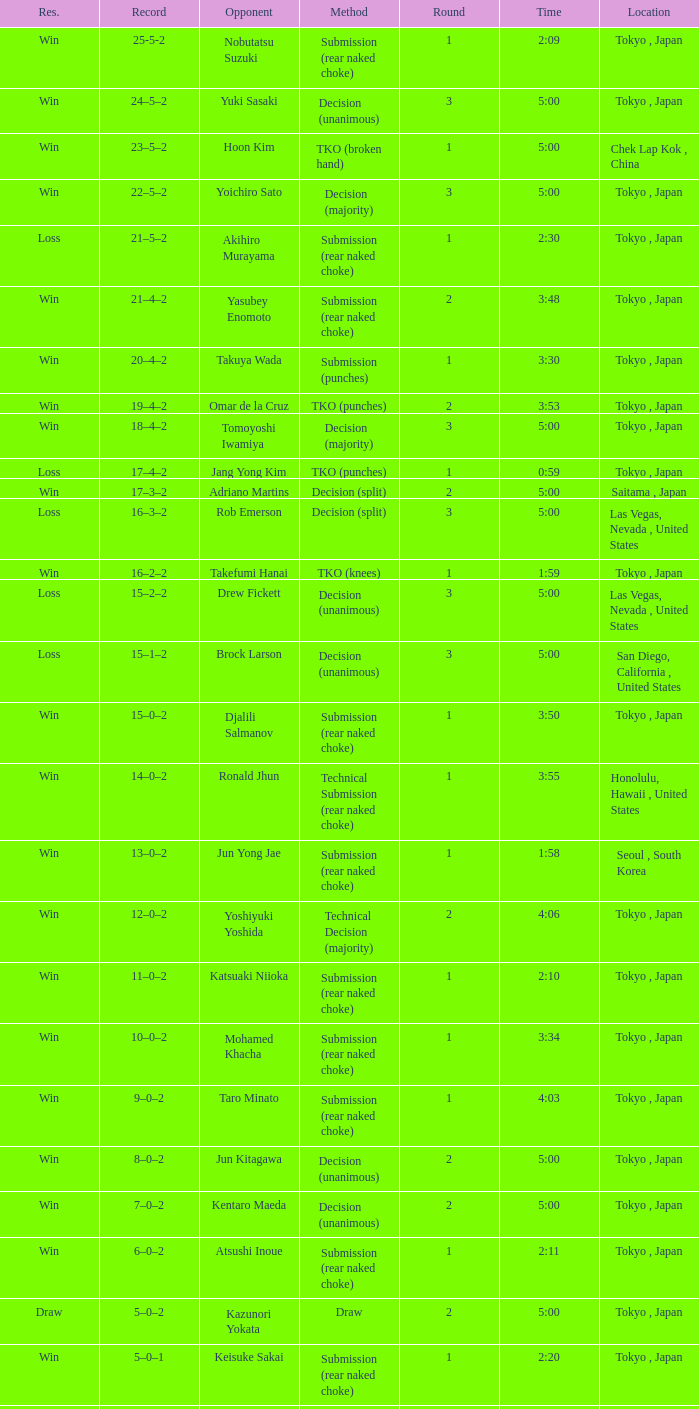What is the total number of rounds when Drew Fickett was the opponent and the time is 5:00? 1.0. 